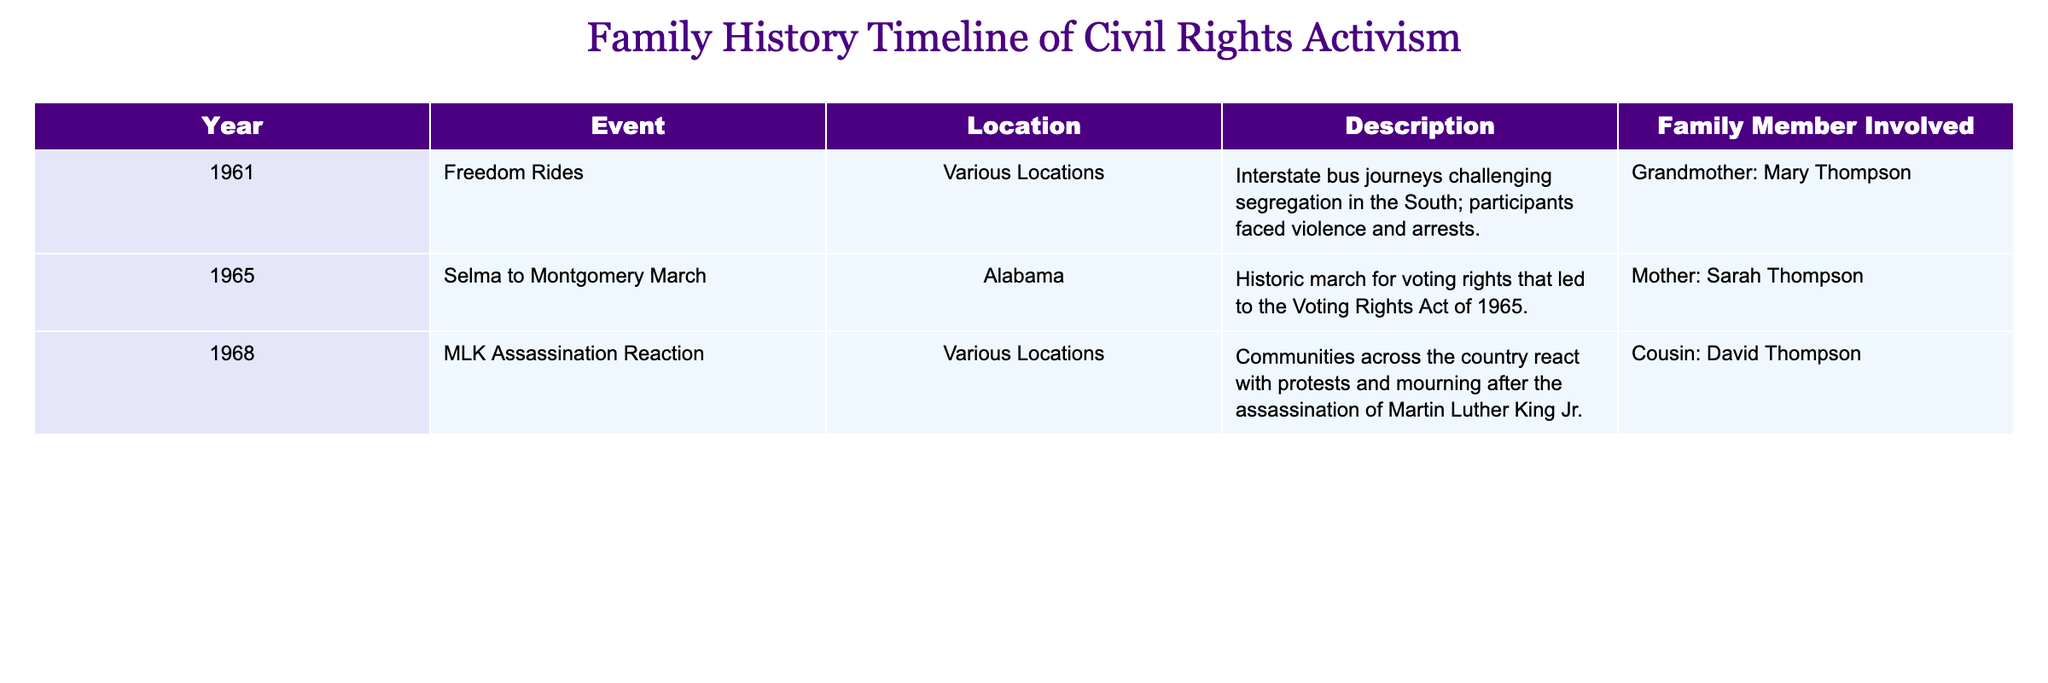What year did the Freedom Rides take place? The table lists the year for the Freedom Rides event in the "Year" column, which is 1961.
Answer: 1961 Who participated in the Selma to Montgomery March? The table indicates that Sarah Thompson participated in the Selma to Montgomery March, as mentioned in the "Family Member Involved" column.
Answer: Mother: Sarah Thompson How many events are listed in the table? There are three rows of events in the table, indicating three significant events related to civil rights activism.
Answer: 3 Was any family member involved in a reaction to the MLK assassination? The table records a reaction to the MLK assassination involving David Thompson, confirming that a family member was indeed involved.
Answer: Yes What is the earliest year mentioned in the timeline of activism? By examining the "Year" column in the table, the earliest year mentioned is 1961, corresponding to the Freedom Rides.
Answer: 1961 Which event took place in Alabama? The table shows that the Selma to Montgomery March took place in Alabama, as specified in the "Location" column.
Answer: Selma to Montgomery March How many family members were involved in activism recorded from 1965 onward? There are two events from 1965 onward; the Selma to Montgomery March involved one family member (Sarah Thompson) and the reaction to the MLK assassination involved another (David Thompson), totaling two members.
Answer: 2 What was the main focus of the Selma to Montgomery March? The description in the table highlights that the Selma to Montgomery March was a historic event focused on voting rights, leading to significant legislation.
Answer: Voting rights List the family members involved in events occurring in 1968. The table indicates that only David Thompson was involved in events occurring in 1968, specifically in reaction to the MLK assassination.
Answer: Cousin: David Thompson 